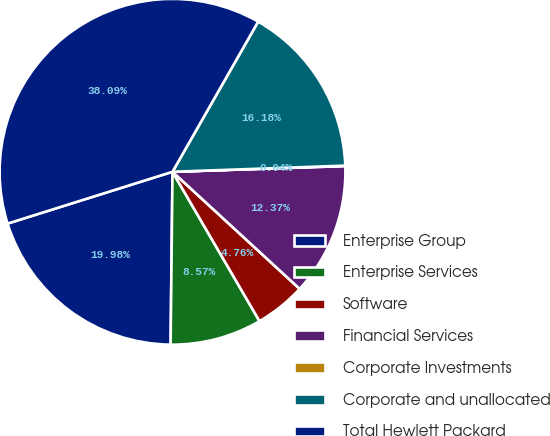<chart> <loc_0><loc_0><loc_500><loc_500><pie_chart><fcel>Enterprise Group<fcel>Enterprise Services<fcel>Software<fcel>Financial Services<fcel>Corporate Investments<fcel>Corporate and unallocated<fcel>Total Hewlett Packard<nl><fcel>19.98%<fcel>8.57%<fcel>4.76%<fcel>12.37%<fcel>0.04%<fcel>16.18%<fcel>38.09%<nl></chart> 